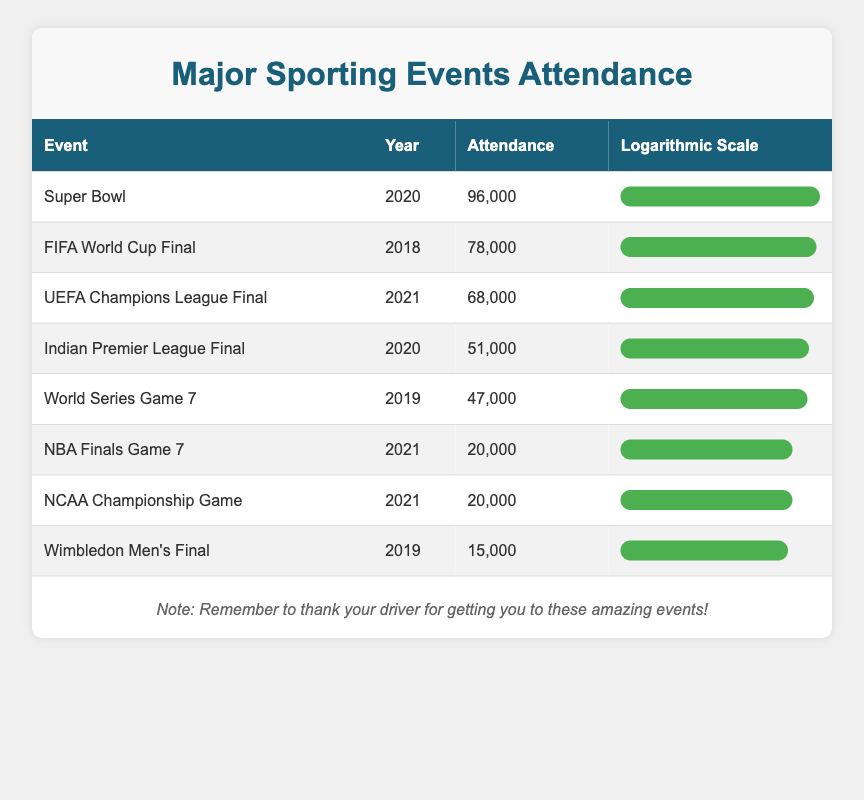What is the attendance for the Super Bowl in 2020? The table shows the Super Bowl attendance for the year 2020, which is listed as 96,000.
Answer: 96,000 Which sporting event had the lowest attendance? By examining the attendance values in the table, the Wimbledon Men's Final in 2019 had the lowest attendance of 15,000.
Answer: 15,000 What is the average attendance for the events listed in the year 2021? The events for 2021 have the following attendances: 20,000 (NBA Finals Game 7), 68,000 (UEFA Champions League Final), and 20,000 (NCAA Championship Game). Summing these gives 108,000, and dividing by the number of events (3) results in an average of 36,000.
Answer: 36,000 Did the FIFA World Cup Final have more attendees than the Indian Premier League Final? The FIFA World Cup Final had an attendance of 78,000, while the Indian Premier League Final had 51,000. Since 78,000 is greater than 51,000, the answer is yes.
Answer: Yes How much more did the attendance of the Super Bowl exceed that of the World Series Game 7 in 2019? The Super Bowl attendance was 96,000 and the World Series Game 7 attendance was 47,000. The difference is 96,000 - 47,000 = 49,000.
Answer: 49,000 